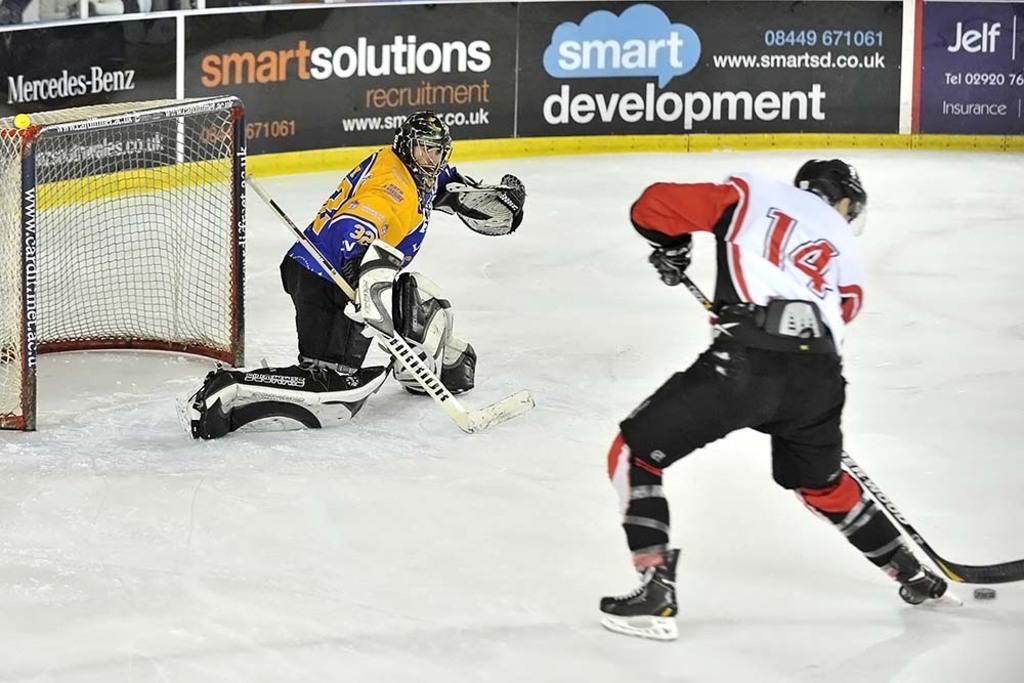How would you summarize this image in a sentence or two? In this picture, we can see two persons playing snow hockey, and we can see some objects on the ground like net with poles, we can see some posters. 